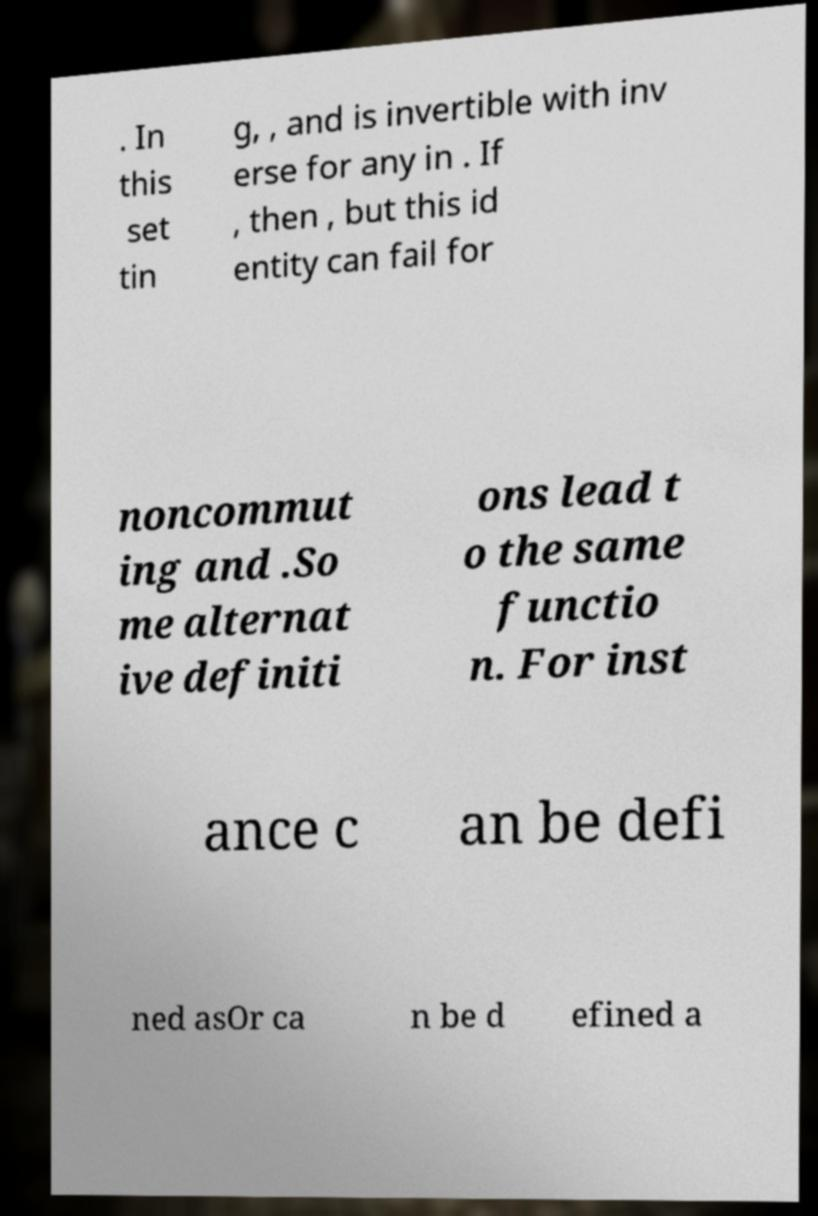Can you read and provide the text displayed in the image?This photo seems to have some interesting text. Can you extract and type it out for me? . In this set tin g, , and is invertible with inv erse for any in . If , then , but this id entity can fail for noncommut ing and .So me alternat ive definiti ons lead t o the same functio n. For inst ance c an be defi ned asOr ca n be d efined a 